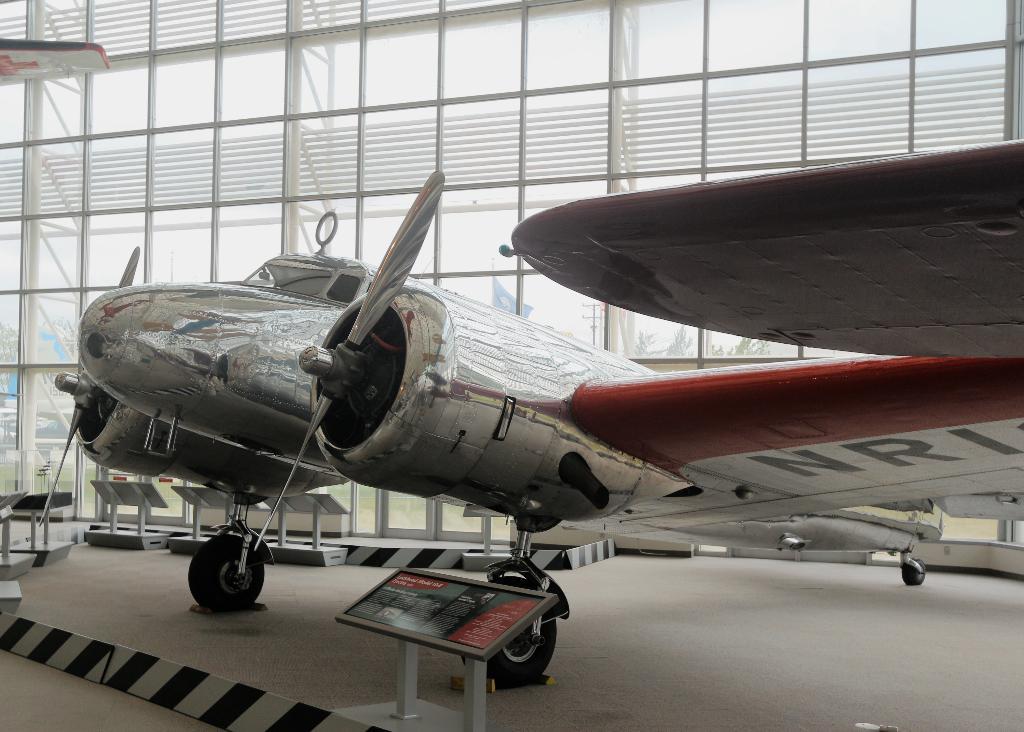What is written under the wing?
Ensure brevity in your answer.  Nri. 